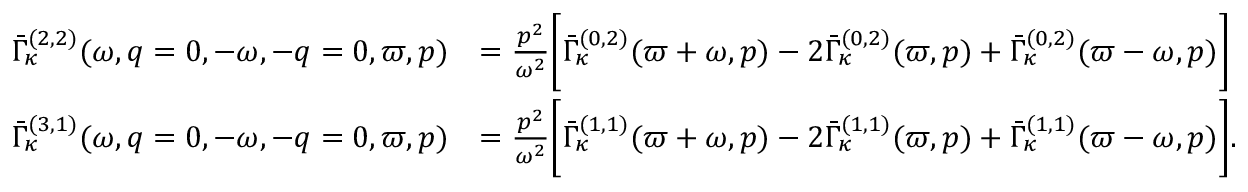<formula> <loc_0><loc_0><loc_500><loc_500>\begin{array} { r l } { \bar { \Gamma } _ { \kappa } ^ { ( 2 , 2 ) } ( \omega , q = 0 , - \omega , - q = 0 , \varpi , p ) } & { = \frac { p ^ { 2 } } { \omega ^ { 2 } } \left [ \bar { \Gamma } _ { \kappa } ^ { ( 0 , 2 ) } ( \varpi + \omega , p ) - 2 \bar { \Gamma } _ { \kappa } ^ { ( 0 , 2 ) } ( \varpi , p ) + \bar { \Gamma } _ { \kappa } ^ { ( 0 , 2 ) } ( \varpi - \omega , p ) \right ] } \\ { \bar { \Gamma } _ { \kappa } ^ { ( 3 , 1 ) } ( \omega , q = 0 , - \omega , - q = 0 , \varpi , p ) } & { = \frac { p ^ { 2 } } { \omega ^ { 2 } } \left [ \bar { \Gamma } _ { \kappa } ^ { ( 1 , 1 ) } ( \varpi + \omega , p ) - 2 \bar { \Gamma } _ { \kappa } ^ { ( 1 , 1 ) } ( \varpi , p ) + \bar { \Gamma } _ { \kappa } ^ { ( 1 , 1 ) } ( \varpi - \omega , p ) \right ] . } \end{array}</formula> 